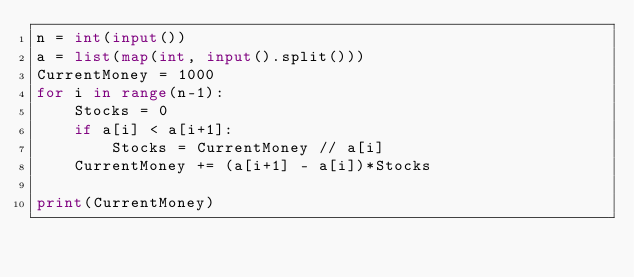Convert code to text. <code><loc_0><loc_0><loc_500><loc_500><_Python_>n = int(input())
a = list(map(int, input().split()))
CurrentMoney = 1000
for i in range(n-1):
    Stocks = 0
    if a[i] < a[i+1]:
        Stocks = CurrentMoney // a[i]
    CurrentMoney += (a[i+1] - a[i])*Stocks

print(CurrentMoney)</code> 